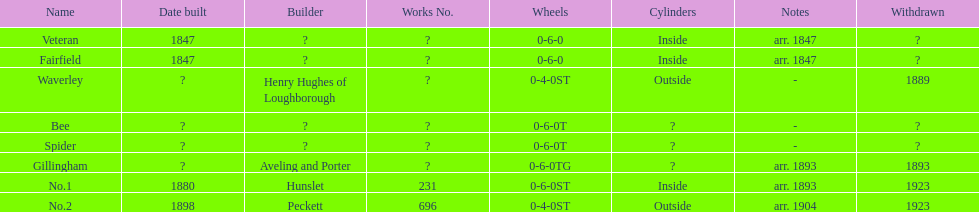What are the alderney railway names? Veteran, Fairfield, Waverley, Bee, Spider, Gillingham, No.1, No.2. When was the farfield built? 1847. What else was built that year? Veteran. 